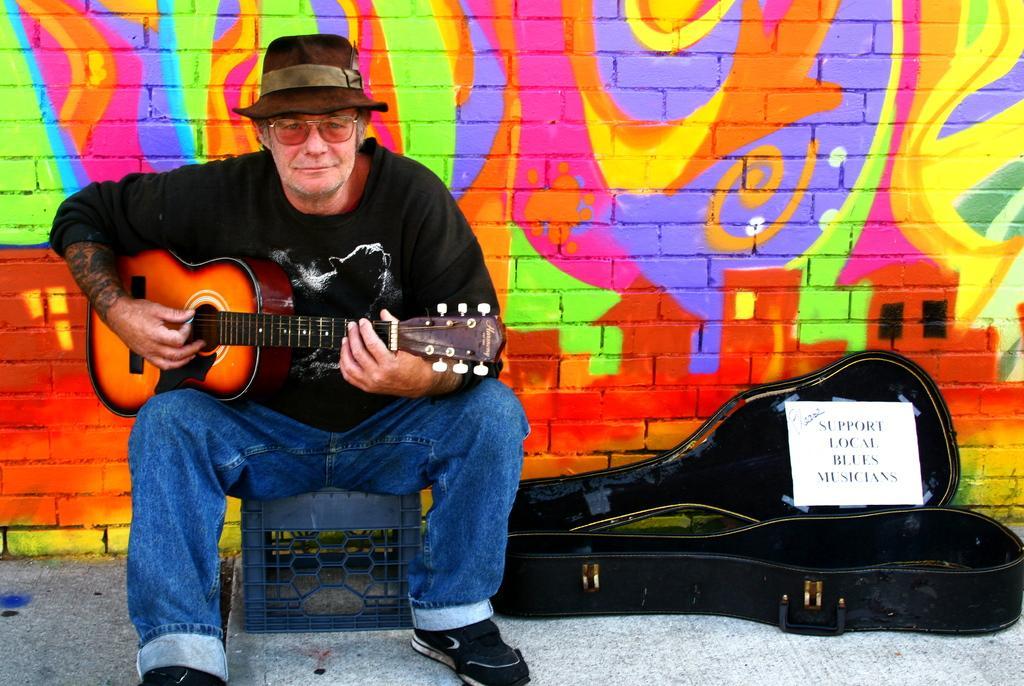In one or two sentences, can you explain what this image depicts? This is the picture of a person who is holding a guitar in his hand and there is a guitar bag beside him. 